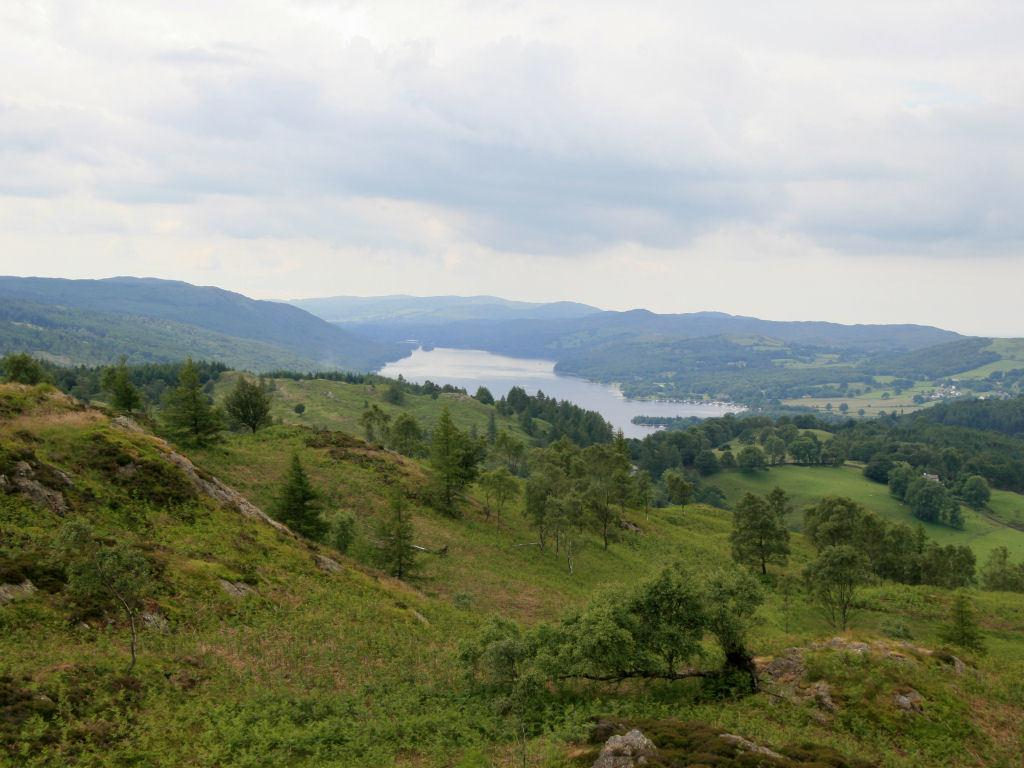What type of vegetation can be seen in the image? There are trees and grass in the image. What natural element is visible in the image? There is water visible in the image. What can be seen in the background of the image? There are hills and the sky visible in the background of the image. Can you see any wrenches or tools being used in the image? There are no wrenches or tools visible in the image; it only features trees, grass, water, hills, and the sky. 